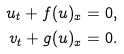Convert formula to latex. <formula><loc_0><loc_0><loc_500><loc_500>u _ { t } + f ( u ) _ { x } & = 0 , \\ v _ { t } + g ( u ) _ { x } & = 0 .</formula> 